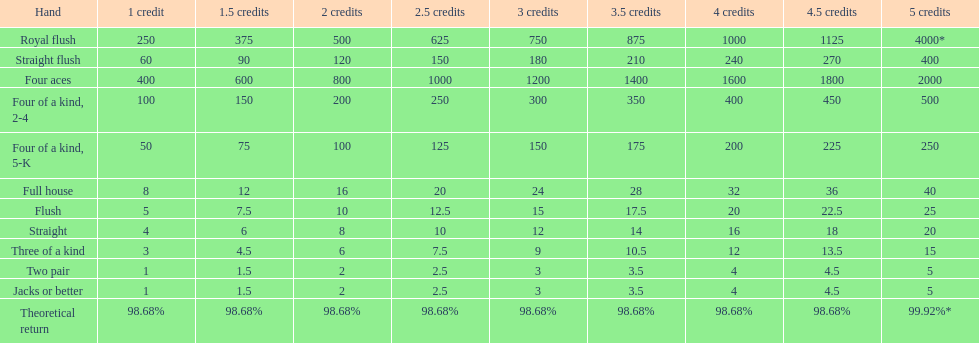What is the complete value of a 3 credit straight flush? 180. 